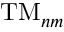Convert formula to latex. <formula><loc_0><loc_0><loc_500><loc_500>T M _ { n m }</formula> 